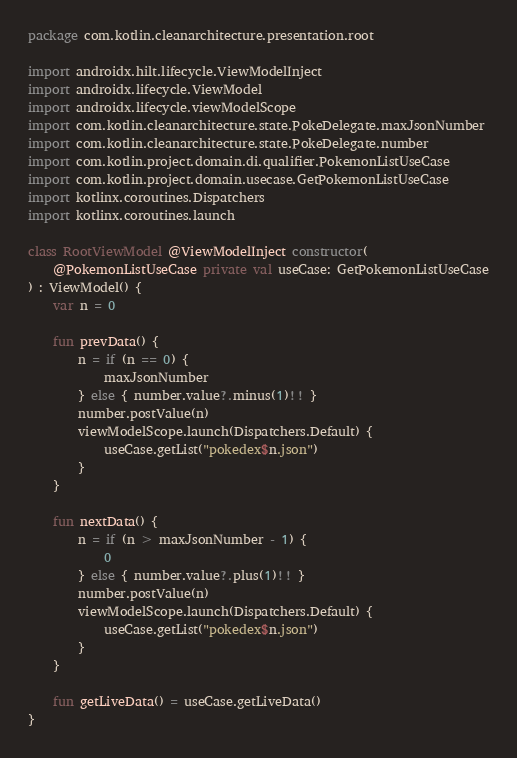Convert code to text. <code><loc_0><loc_0><loc_500><loc_500><_Kotlin_>package com.kotlin.cleanarchitecture.presentation.root

import androidx.hilt.lifecycle.ViewModelInject
import androidx.lifecycle.ViewModel
import androidx.lifecycle.viewModelScope
import com.kotlin.cleanarchitecture.state.PokeDelegate.maxJsonNumber
import com.kotlin.cleanarchitecture.state.PokeDelegate.number
import com.kotlin.project.domain.di.qualifier.PokemonListUseCase
import com.kotlin.project.domain.usecase.GetPokemonListUseCase
import kotlinx.coroutines.Dispatchers
import kotlinx.coroutines.launch

class RootViewModel @ViewModelInject constructor(
    @PokemonListUseCase private val useCase: GetPokemonListUseCase
) : ViewModel() {
    var n = 0

    fun prevData() {
        n = if (n == 0) {
            maxJsonNumber
        } else { number.value?.minus(1)!! }
        number.postValue(n)
        viewModelScope.launch(Dispatchers.Default) {
            useCase.getList("pokedex$n.json")
        }
    }

    fun nextData() {
        n = if (n > maxJsonNumber - 1) {
            0
        } else { number.value?.plus(1)!! }
        number.postValue(n)
        viewModelScope.launch(Dispatchers.Default) {
            useCase.getList("pokedex$n.json")
        }
    }

    fun getLiveData() = useCase.getLiveData()
}
</code> 